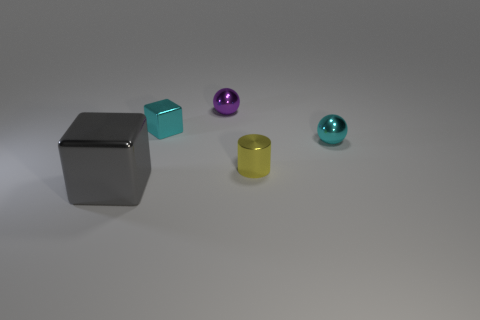Add 2 large brown things. How many objects exist? 7 Subtract all gray cubes. How many cubes are left? 1 Subtract all cubes. How many objects are left? 3 Subtract 1 cylinders. How many cylinders are left? 0 Subtract all green spheres. How many cyan cubes are left? 1 Subtract all purple things. Subtract all cyan balls. How many objects are left? 3 Add 5 tiny purple objects. How many tiny purple objects are left? 6 Add 1 large metal objects. How many large metal objects exist? 2 Subtract 0 gray cylinders. How many objects are left? 5 Subtract all blue cubes. Subtract all cyan cylinders. How many cubes are left? 2 